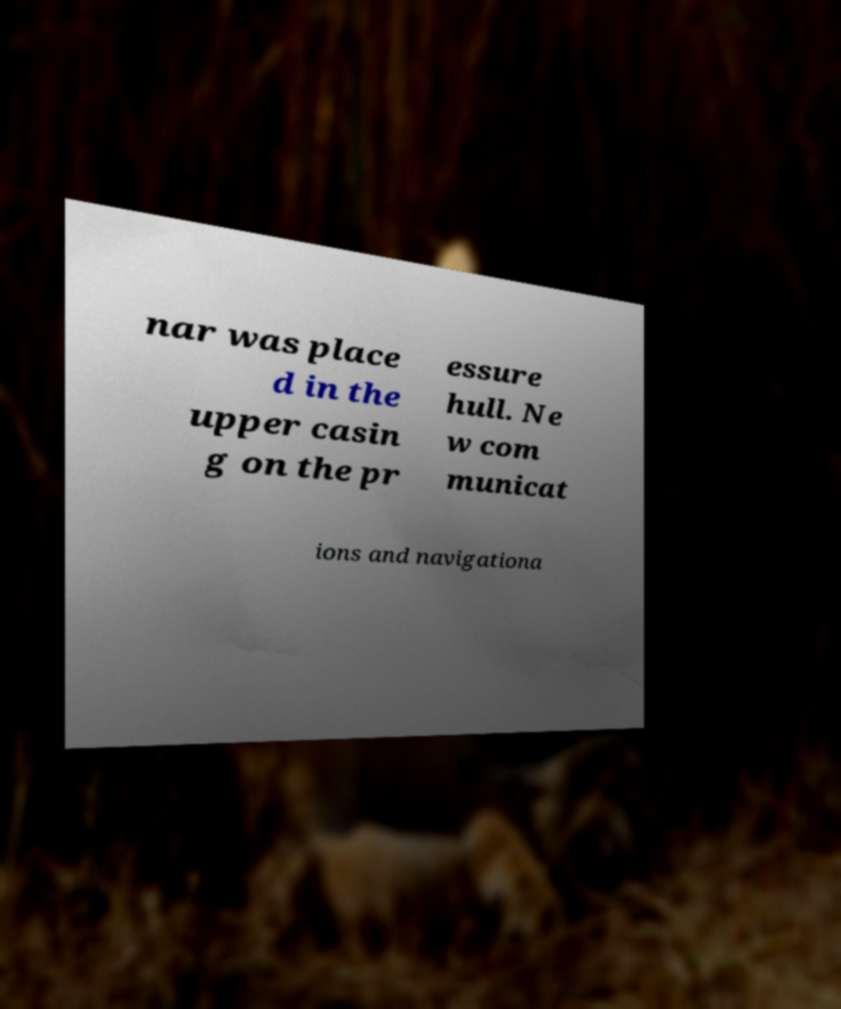I need the written content from this picture converted into text. Can you do that? nar was place d in the upper casin g on the pr essure hull. Ne w com municat ions and navigationa 